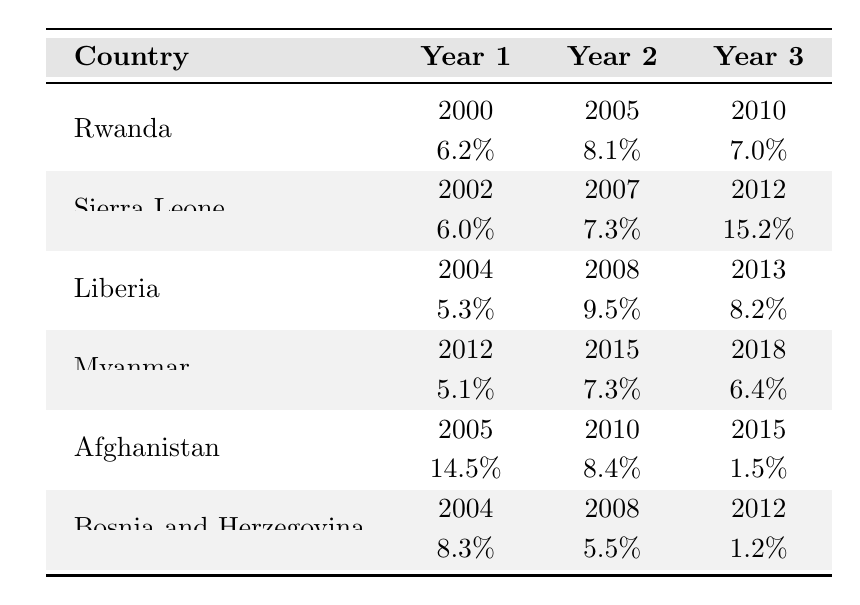What was Rwanda's economic growth rate in 2005? The table shows that in 2005, Rwanda had an economic growth rate of 8.1%.
Answer: 8.1% Which country had the highest economic growth rate in 2012? In the table, Sierra Leone has the highest economic growth rate in 2012 at 15.2%.
Answer: Sierra Leone What is the average economic growth rate of Liberia from 2004 to 2013? The growth rates for Liberia from 2004 (5.3%), 2008 (9.5%), and 2013 (8.2%) sum to 23.0%. The average is 23.0% / 3 = 7.67%.
Answer: 7.67% Which country experienced a decrease in economic growth rate from 2008 to 2012? By examining the table, Bosnia and Herzegovina's growth dropped from 5.5% in 2008 to 1.2% in 2012.
Answer: Bosnia and Herzegovina What was the difference in economic growth rates between Afghanistan in 2005 and 2015? Afghanistan's growth rates were 14.5% in 2005 and 1.5% in 2015. The difference is 14.5% - 1.5% = 13%.
Answer: 13% Did Myanmar's economic growth rate increase in every year between 2012 and 2018? Looking at the table, Myanmar's rates were 5.1% in 2012, 7.3% in 2015, and 6.4% in 2018, showing a decrease from 2015 to 2018.
Answer: No What is the trend in economic growth rates for Sierra Leone from 2002 to 2012? The table indicates that Sierra Leone's growth rates increased from 6.0% in 2002 to 15.2% in 2012, showing a positive trend.
Answer: Increasing Which country's economic growth rate was consistent from 2000 to 2010? Rwanda's growth rates were 6.2% in 2000, 8.1% in 2005, and 7.0% in 2010, indicating some fluctuation but not consistency as the values differ.
Answer: None How does the economic growth rate of Bosnia and Herzegovina in 2012 compare to Liberia's in 2013? Bosnia and Herzegovina had a growth rate of 1.2% in 2012, while Liberia had 8.2% in 2013; thus, Liberia's rate is higher.
Answer: Liberia's rate is higher What is the sum of the economic growth rates for Rwanda across all provided years? The growth rates for Rwanda (6.2% + 8.1% + 7.0%) total to 21.3%.
Answer: 21.3% 